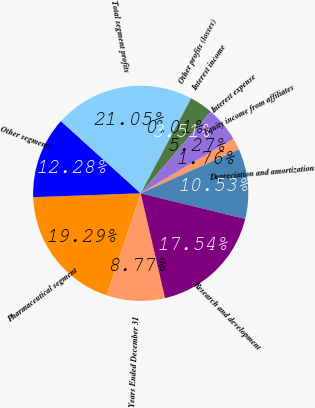Convert chart. <chart><loc_0><loc_0><loc_500><loc_500><pie_chart><fcel>Years Ended December 31<fcel>Pharmaceutical segment<fcel>Other segments<fcel>Total segment profits<fcel>Other profits (losses)<fcel>Interest income<fcel>Interest expense<fcel>Equity income from affiliates<fcel>Depreciation and amortization<fcel>Research and development<nl><fcel>8.77%<fcel>19.29%<fcel>12.28%<fcel>21.05%<fcel>0.01%<fcel>3.51%<fcel>5.27%<fcel>1.76%<fcel>10.53%<fcel>17.54%<nl></chart> 